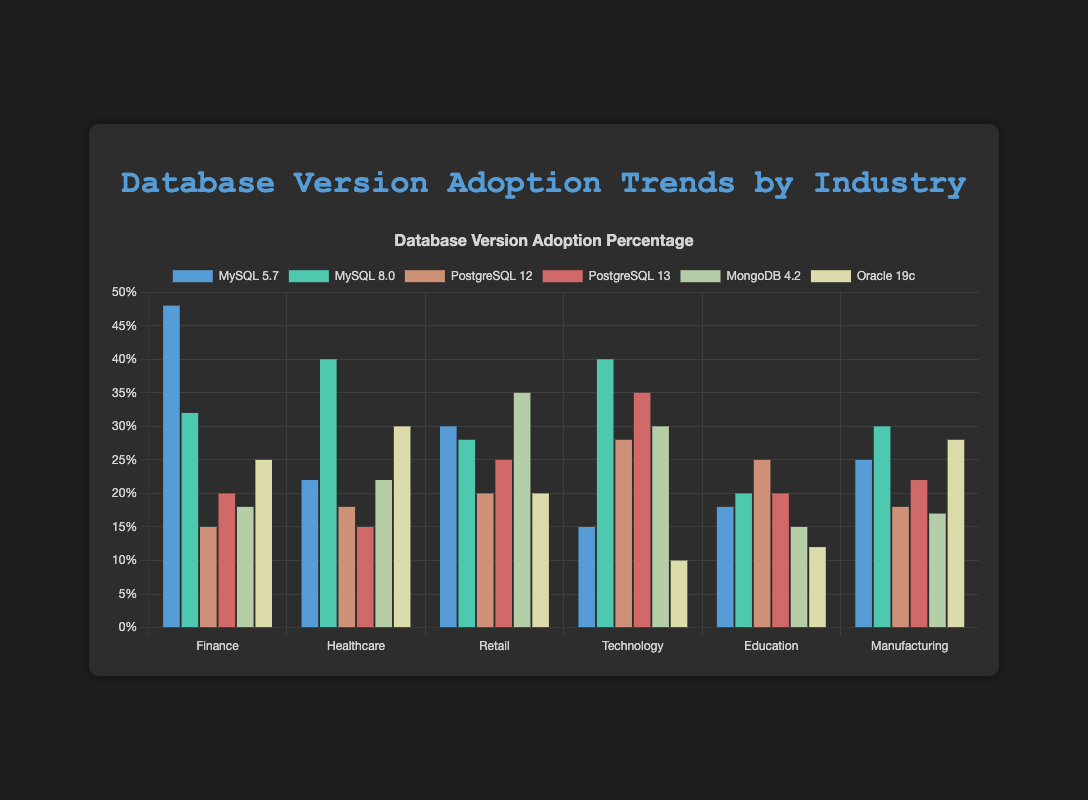What's the most adopted database version in the Finance industry? To find the most adopted database version in the Finance industry, we look at the highest bar in the Finance category. MySQL 5.7 has the highest value with 48%.
Answer: MySQL 5.7 Which industry has the highest adoption of MySQL 8.0? To determine which industry has the highest adoption of MySQL 8.0, look for the tallest MySQL 8.0 bar. The Healthcare and Technology industries both have the highest values with 40%.
Answer: Healthcare, Technology What is the total adoption percentage of PostgreSQL (both versions) in the Technology industry? Sum the values of PostgreSQL 12 and PostgreSQL 13 for the Technology industry: 28% + 35% = 63%.
Answer: 63% Compare the adoption of MongoDB 4.2 in the Retail and Education industries. To compare, look at the heights of the MongoDB 4.2 bars. MongoDB 4.2 adoption in Retail is 35%, while in Education it is 15%.
Answer: Retail has higher adoption Which database version has the least adoption in the Education industry? Look for the shortest bar under the Education industry. Oracle 19c has the least adoption with 12%.
Answer: Oracle 19c What's the average adoption rate of MySQL 5.7 across all industries? Sum the MySQL 5.7 values: 48 + 22 + 30 + 15 + 18 + 25 = 158. There are 6 industries, so the average is 158 / 6 = 26.33%.
Answer: 26.33% What is the difference in PostgreSQL 13 adoption between the Retail and Manufacturing industries? Subtract the PostgreSQL 13 value for Manufacturing from the value for Retail: 25% - 22% = 3%.
Answer: 3% In which industry is Oracle 19c more popular than MySQL 8.0? Compare Oracle 19c to MySQL 8.0 within each industry. In the Manufacturing industry, Oracle 19c (28%) is more popular than MySQL 8.0 (30%).
Answer: None Which industry has the highest combined adoption percentage of all database versions? Sum the values of all database versions for each industry, compare which is greatest:
Finance: 48+32+15+20+18+25 = 158
Healthcare: 22+40+18+15+22+30 = 147
Retail: 30+28+20+25+35+20 = 158
Technology: 15+40+28+35+30+10 = 158
Education: 18+20+25+20+15+12 = 110
Manufacturing: 25+30+18+22+17+28 = 140
Finance, Retail and Technology have the highest combined adoption percentages with 158% each.
Answer: Finance, Retail, Technology What is the percentage difference between the highest and lowest adopting industries for MySQL 8.0? Identify the highest and lowest values for MySQL 8.0 and compute the difference: Highest 40% (in Healthcare and Technology) and Lowest 20% (in Education). The percentage difference is 40% - 20% = 20%.
Answer: 20% 